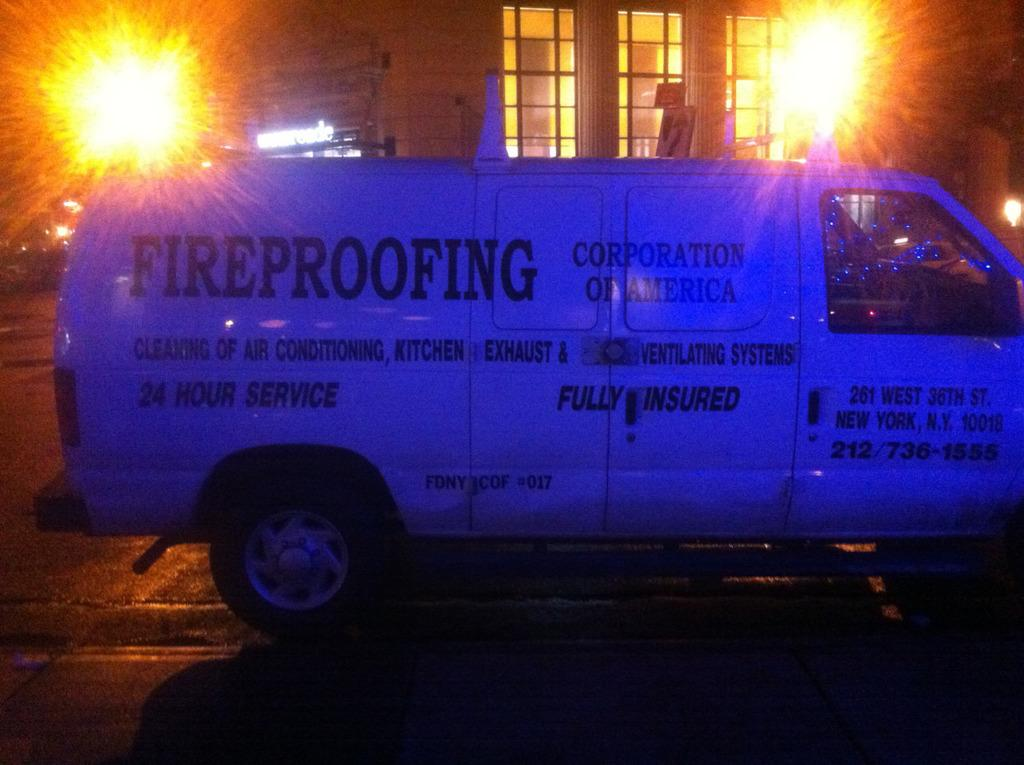<image>
Offer a succinct explanation of the picture presented. A van that says "FIREPROOFING" on the side is parked in front of a building at night. 